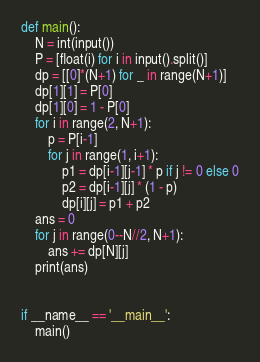<code> <loc_0><loc_0><loc_500><loc_500><_Python_>def main():
    N = int(input())
    P = [float(i) for i in input().split()]
    dp = [[0]*(N+1) for _ in range(N+1)]
    dp[1][1] = P[0]
    dp[1][0] = 1 - P[0]
    for i in range(2, N+1):
        p = P[i-1]
        for j in range(1, i+1):
            p1 = dp[i-1][j-1] * p if j != 0 else 0
            p2 = dp[i-1][j] * (1 - p)
            dp[i][j] = p1 + p2
    ans = 0
    for j in range(0--N//2, N+1):
        ans += dp[N][j]
    print(ans)


if __name__ == '__main__':
    main()
</code> 